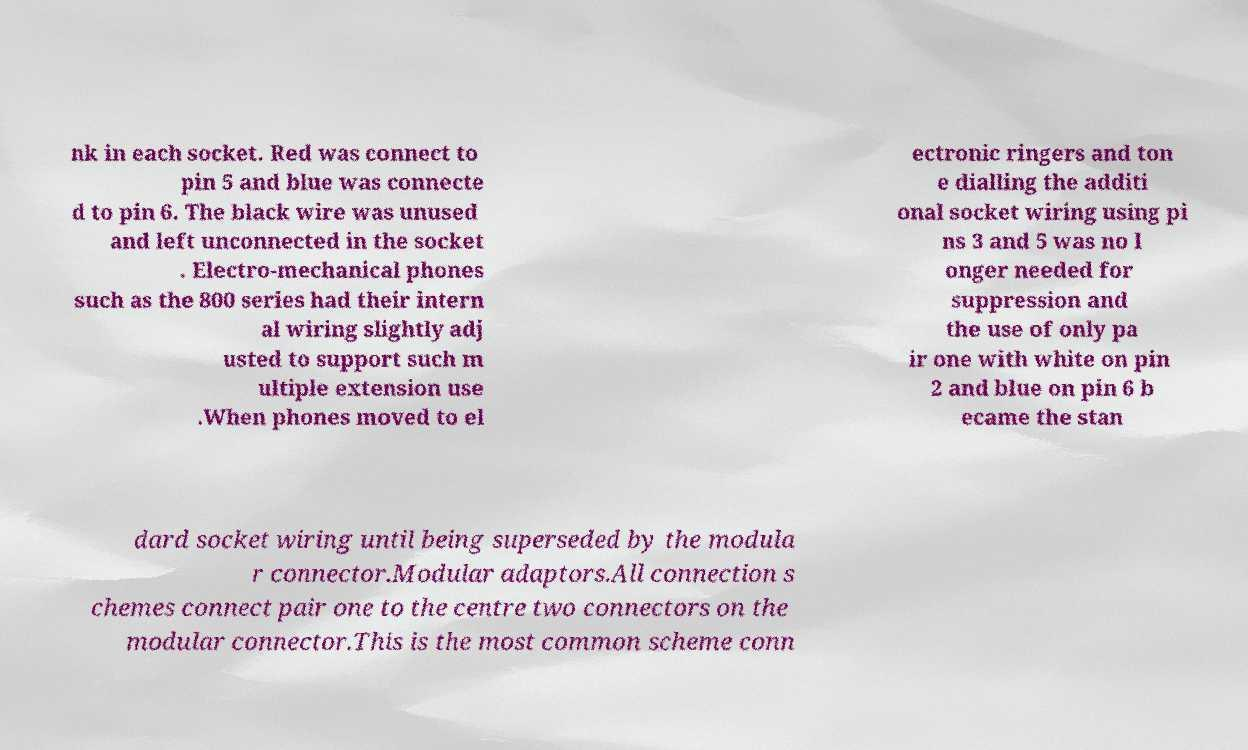Could you assist in decoding the text presented in this image and type it out clearly? nk in each socket. Red was connect to pin 5 and blue was connecte d to pin 6. The black wire was unused and left unconnected in the socket . Electro-mechanical phones such as the 800 series had their intern al wiring slightly adj usted to support such m ultiple extension use .When phones moved to el ectronic ringers and ton e dialling the additi onal socket wiring using pi ns 3 and 5 was no l onger needed for suppression and the use of only pa ir one with white on pin 2 and blue on pin 6 b ecame the stan dard socket wiring until being superseded by the modula r connector.Modular adaptors.All connection s chemes connect pair one to the centre two connectors on the modular connector.This is the most common scheme conn 